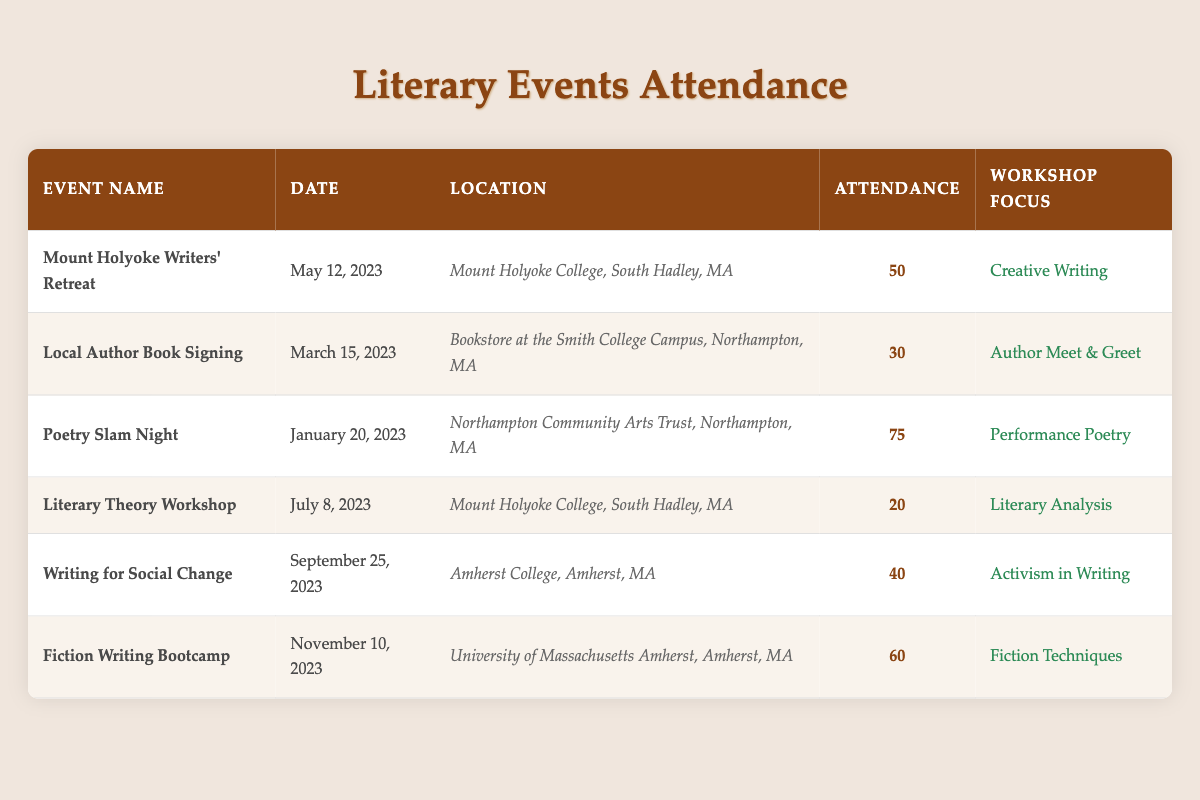What is the attendance for the "Poetry Slam Night"? The table lists "Poetry Slam Night" under the "Event Name" column, with the corresponding attendance value of 75 under the "Attendance" column.
Answer: 75 What is the date of the "Literary Theory Workshop"? The date for "Literary Theory Workshop" is found in the table in the "Date" column next to the event name, which shows July 8, 2023.
Answer: July 8, 2023 How many attendees were there for events held at Mount Holyoke College? Two events were held at Mount Holyoke College: "Mount Holyoke Writers' Retreat" with 50 attendees and "Literary Theory Workshop" with 20 attendees. Adding these gives us 50 + 20 = 70 attendees total.
Answer: 70 Which event had the lowest attendance? By reviewing the attendance column, "Literary Theory Workshop" had the lowest attendance of 20, which is lower than all other attendance values.
Answer: 20 Was there an event with more than 60 attendees? "Poetry Slam Night" with 75 attendees and "Fiction Writing Bootcamp" with 60 attendees both have attendance figures above 60. Thus, yes, there was at least one event with more than 60 attendees.
Answer: Yes What is the average attendance of all the events listed? The total attendance of all events is 50 + 30 + 75 + 20 + 40 + 60 = 275. There are 6 events, so the average attendance is 275 divided by 6, which equals approximately 45.83.
Answer: 45.83 How many events focused on "Creative Writing" compared to those that were not? Looking at the "Workshop Focus" column, only one event, "Mount Holyoke Writers' Retreat," focused on "Creative Writing." The remaining five events did not, so there is 1 event with that focus and 5 without.
Answer: 1 focused, 5 not focused Which event attracted the largest audience, and what was the attendance? By checking the attendance numbers, "Poetry Slam Night" had the largest audience with an attendance of 75. Thus, the largest audience was for "Poetry Slam Night."
Answer: Poetry Slam Night, 75 attendees How many events took place in the summer months (June, July, August)? In the provided data, only the "Literary Theory Workshop" on July 8 is listed, indicating that there was 1 event that took place in the summer months.
Answer: 1 